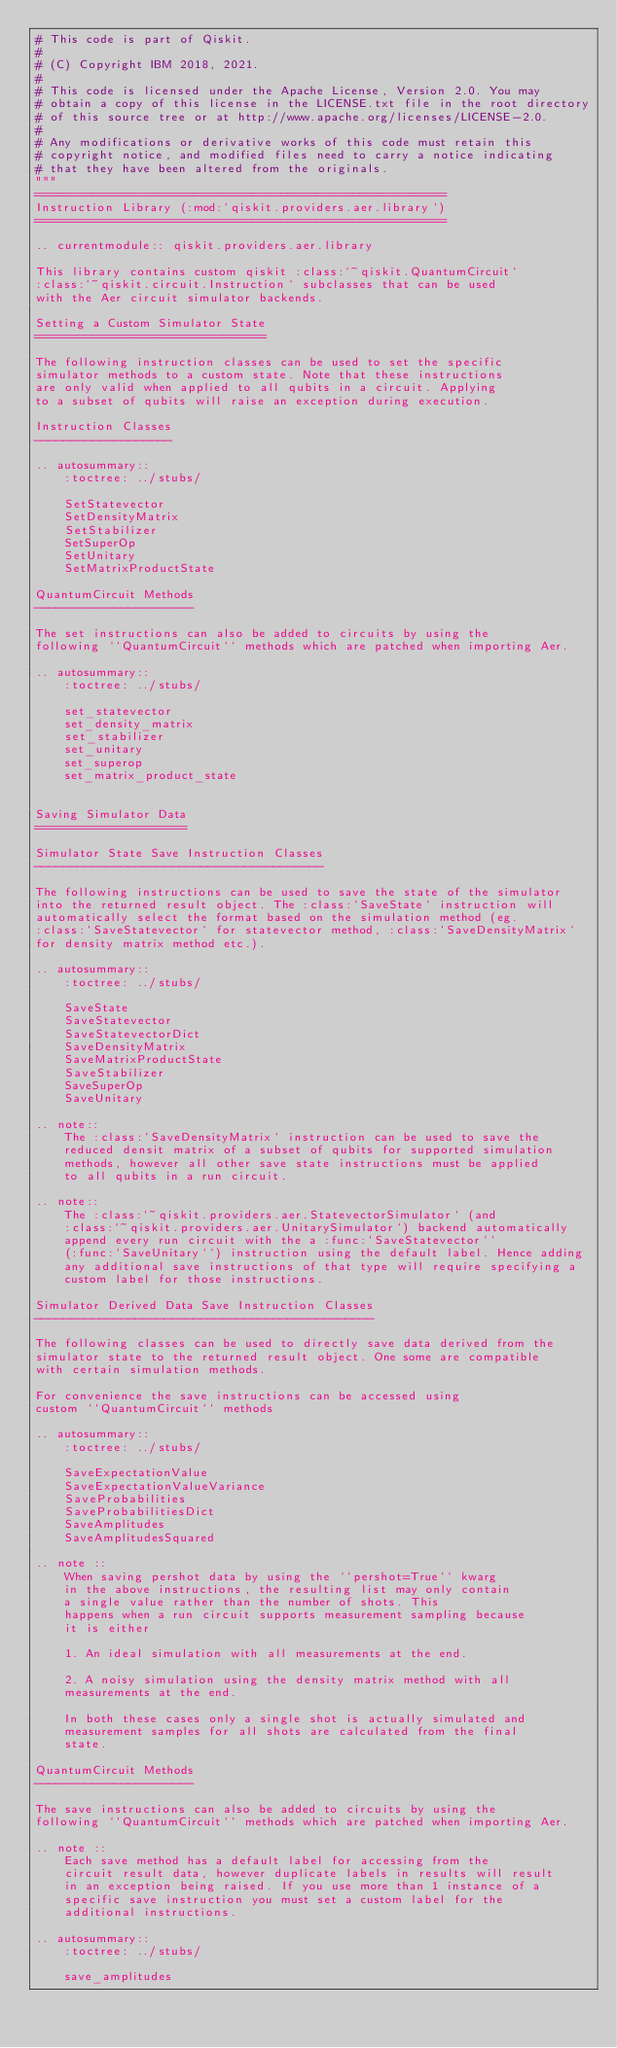Convert code to text. <code><loc_0><loc_0><loc_500><loc_500><_Python_># This code is part of Qiskit.
#
# (C) Copyright IBM 2018, 2021.
#
# This code is licensed under the Apache License, Version 2.0. You may
# obtain a copy of this license in the LICENSE.txt file in the root directory
# of this source tree or at http://www.apache.org/licenses/LICENSE-2.0.
#
# Any modifications or derivative works of this code must retain this
# copyright notice, and modified files need to carry a notice indicating
# that they have been altered from the originals.
"""
=========================================================
Instruction Library (:mod:`qiskit.providers.aer.library`)
=========================================================

.. currentmodule:: qiskit.providers.aer.library

This library contains custom qiskit :class:`~qiskit.QuantumCircuit`
:class:`~qiskit.circuit.Instruction` subclasses that can be used
with the Aer circuit simulator backends.

Setting a Custom Simulator State
================================

The following instruction classes can be used to set the specific
simulator methods to a custom state. Note that these instructions
are only valid when applied to all qubits in a circuit. Applying
to a subset of qubits will raise an exception during execution.

Instruction Classes
-------------------

.. autosummary::
    :toctree: ../stubs/

    SetStatevector
    SetDensityMatrix
    SetStabilizer
    SetSuperOp
    SetUnitary
    SetMatrixProductState

QuantumCircuit Methods
----------------------

The set instructions can also be added to circuits by using the
following ``QuantumCircuit`` methods which are patched when importing Aer.

.. autosummary::
    :toctree: ../stubs/

    set_statevector
    set_density_matrix
    set_stabilizer
    set_unitary
    set_superop
    set_matrix_product_state


Saving Simulator Data
=====================

Simulator State Save Instruction Classes
----------------------------------------

The following instructions can be used to save the state of the simulator
into the returned result object. The :class:`SaveState` instruction will
automatically select the format based on the simulation method (eg.
:class:`SaveStatevector` for statevector method, :class:`SaveDensityMatrix`
for density matrix method etc.).

.. autosummary::
    :toctree: ../stubs/

    SaveState
    SaveStatevector
    SaveStatevectorDict
    SaveDensityMatrix
    SaveMatrixProductState
    SaveStabilizer
    SaveSuperOp
    SaveUnitary

.. note::
    The :class:`SaveDensityMatrix` instruction can be used to save the
    reduced densit matrix of a subset of qubits for supported simulation
    methods, however all other save state instructions must be applied
    to all qubits in a run circuit.

.. note::
    The :class:`~qiskit.providers.aer.StatevectorSimulator` (and
    :class:`~qiskit.providers.aer.UnitarySimulator`) backend automatically
    append every run circuit with the a :func:`SaveStatevector``
    (:func:`SaveUnitary``) instruction using the default label. Hence adding
    any additional save instructions of that type will require specifying a
    custom label for those instructions.

Simulator Derived Data Save Instruction Classes
-----------------------------------------------

The following classes can be used to directly save data derived from the
simulator state to the returned result object. One some are compatible
with certain simulation methods.

For convenience the save instructions can be accessed using
custom ``QuantumCircuit`` methods

.. autosummary::
    :toctree: ../stubs/

    SaveExpectationValue
    SaveExpectationValueVariance
    SaveProbabilities
    SaveProbabilitiesDict
    SaveAmplitudes
    SaveAmplitudesSquared

.. note ::
    When saving pershot data by using the ``pershot=True`` kwarg
    in the above instructions, the resulting list may only contain
    a single value rather than the number of shots. This
    happens when a run circuit supports measurement sampling because
    it is either

    1. An ideal simulation with all measurements at the end.

    2. A noisy simulation using the density matrix method with all
    measurements at the end.

    In both these cases only a single shot is actually simulated and
    measurement samples for all shots are calculated from the final
    state.

QuantumCircuit Methods
----------------------

The save instructions can also be added to circuits by using the
following ``QuantumCircuit`` methods which are patched when importing Aer.

.. note ::
    Each save method has a default label for accessing from the
    circuit result data, however duplicate labels in results will result
    in an exception being raised. If you use more than 1 instance of a
    specific save instruction you must set a custom label for the
    additional instructions.

.. autosummary::
    :toctree: ../stubs/

    save_amplitudes</code> 